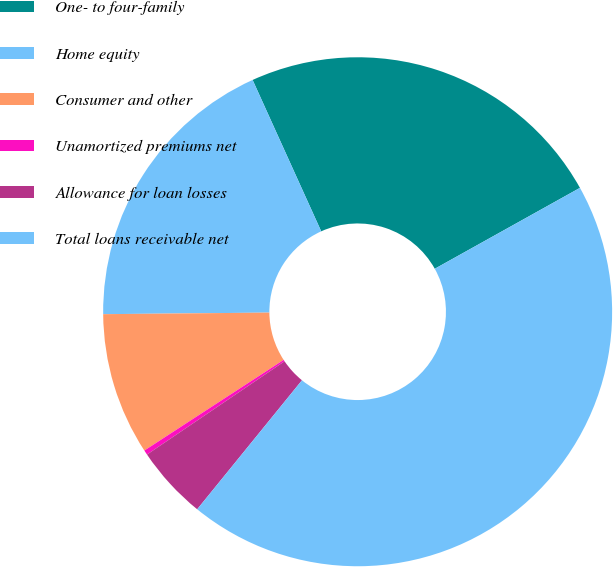Convert chart to OTSL. <chart><loc_0><loc_0><loc_500><loc_500><pie_chart><fcel>One- to four-family<fcel>Home equity<fcel>Consumer and other<fcel>Unamortized premiums net<fcel>Allowance for loan losses<fcel>Total loans receivable net<nl><fcel>23.68%<fcel>18.38%<fcel>9.03%<fcel>0.3%<fcel>4.66%<fcel>43.95%<nl></chart> 